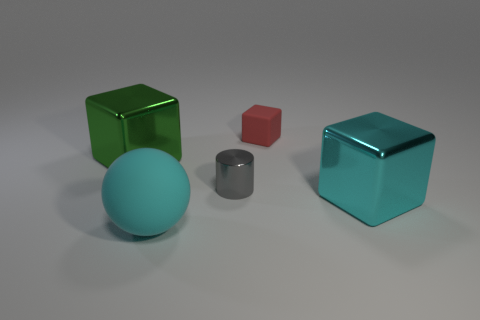If these objects were part of a puzzle, how do you think they might fit together? If we were to conceptualize these objects as puzzle pieces, one might speculate that their varying sizes could correspond to different roles within the puzzle. The larger teal and green cubes could be cornerstones of the structure, while the red and gray pieces might fit in between as connectors or keys to solving the challenge, creating a balance and structure in a hypothetical 3D puzzle. 